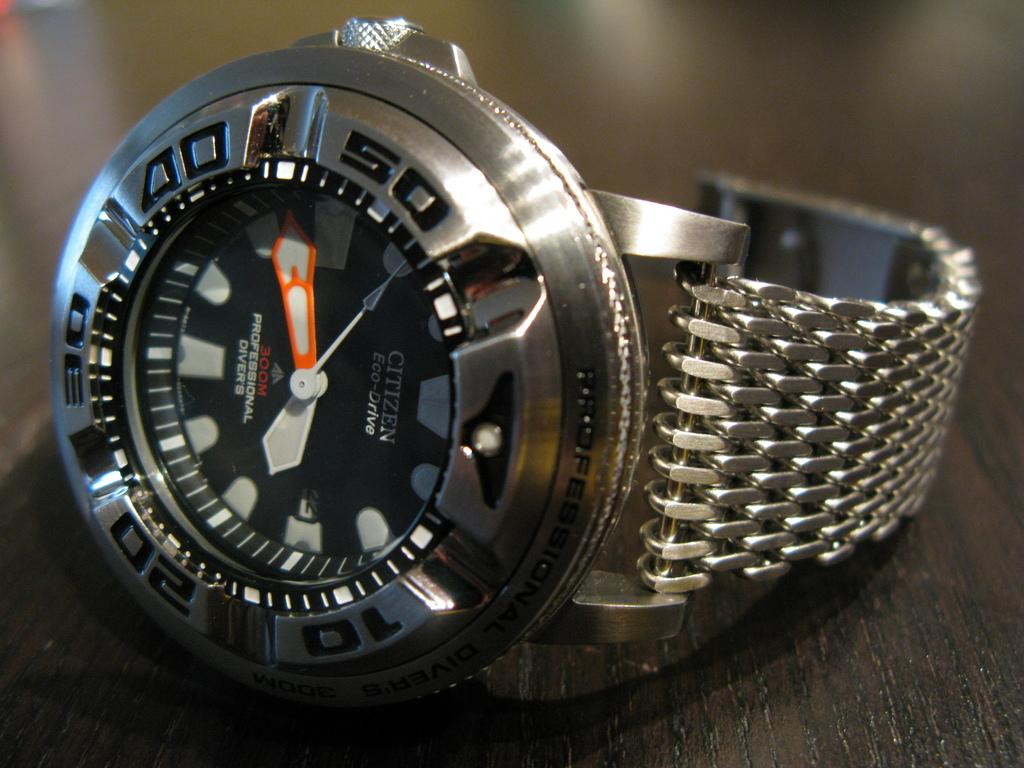<image>
Relay a brief, clear account of the picture shown. Black and Silver Citizen Eco-Drive professional diver's watch. 